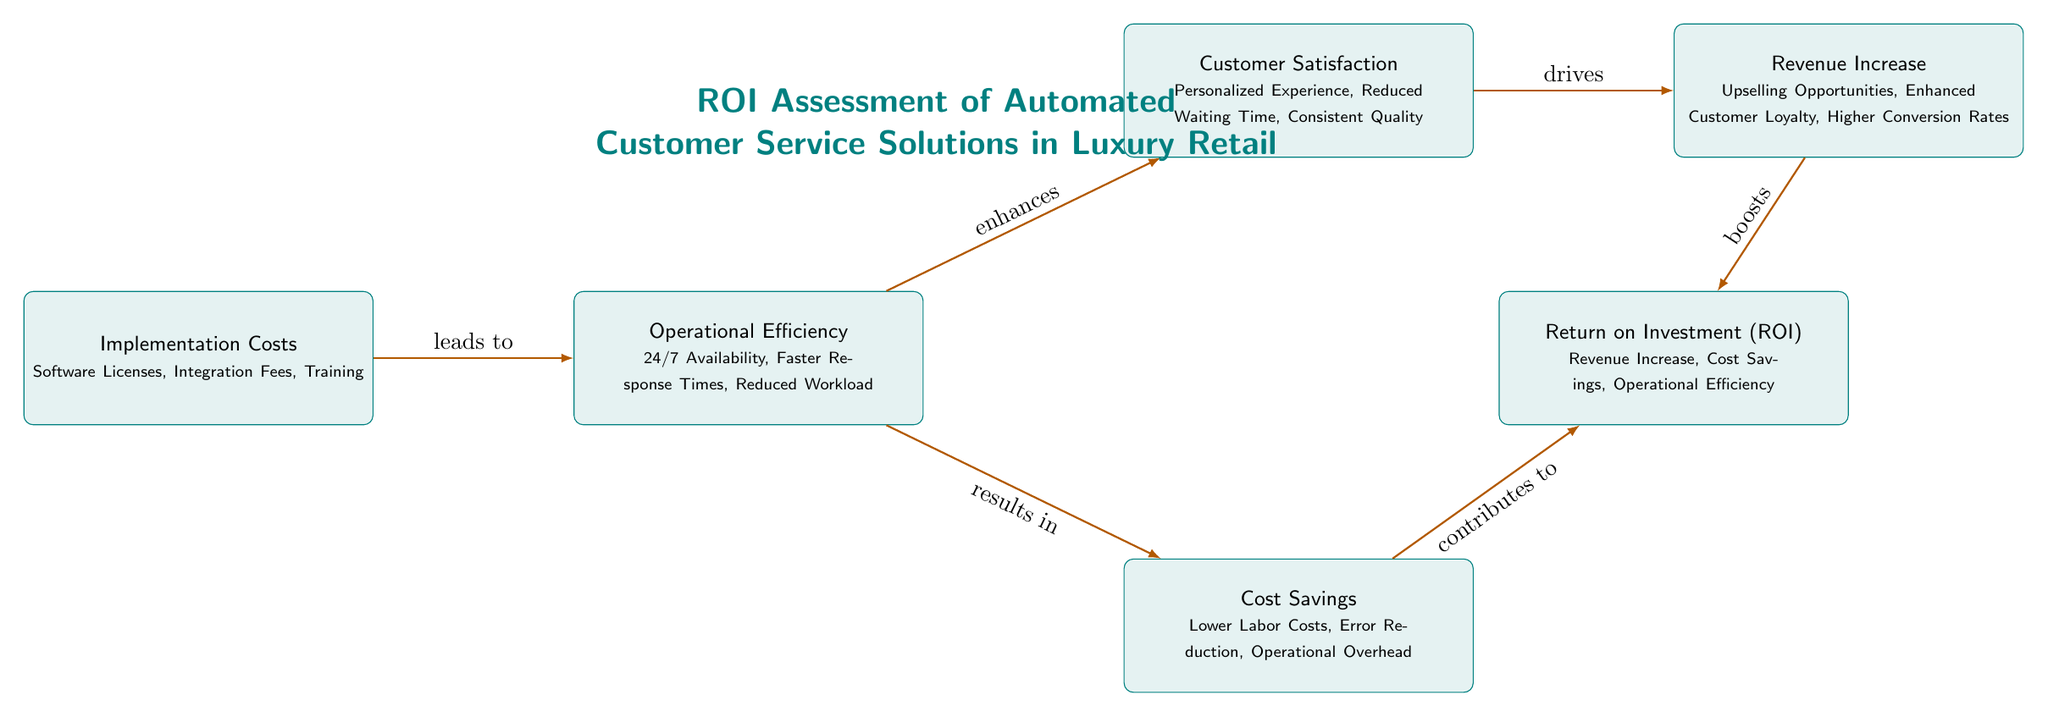What's the first node in the diagram? The first node in the diagram represents "Implementation Costs," which includes specific items like Software Licenses, Integration Fees, and Training. This can be identified as the leftmost node in the flow.
Answer: Implementation Costs How many nodes are present in the diagram? By counting all the rectangular boxes in the diagram, we find there are a total of six nodes. Each node conveys a specific part of the ROI assessment process.
Answer: 6 What does the operational efficiency node enhance? The operational efficiency node enhances customer satisfaction, indicated by the arrow pointing from operational efficiency to the customer satisfaction node.
Answer: Customer Satisfaction Which nodes contribute to the return on investment (ROI)? The node for cost savings contributes to ROI and is directly connected to the ROI node with an arrow, along with revenue increase. Both nodes provide benefits that lead to ROI.
Answer: Cost Savings, Revenue Increase What is the relationship between implementation costs and operational efficiency? The diagram indicates that implementation costs lead to operational efficiency, shown by an arrow pointing from the implementation costs node to operational efficiency.
Answer: Leads to Which node is connected to revenue increase? The revenue increase node is connected to customer satisfaction, indicating that increased satisfaction drives revenue. The diagram emphasizes that higher customer satisfaction leads to higher revenue.
Answer: Customer Satisfaction What aspect does cost savings affect in terms of ROI? Cost savings contribute to ROI via its relationship illustrated with an arrow pointing to the ROI node. This means cost savings positively impact the overall return on investment.
Answer: ROI What is the last node in the diagram? The last node in the diagram is the Return on Investment (ROI) node, located on the far right side, summarizing the results from all previous nodes.
Answer: Return on Investment (ROI) 